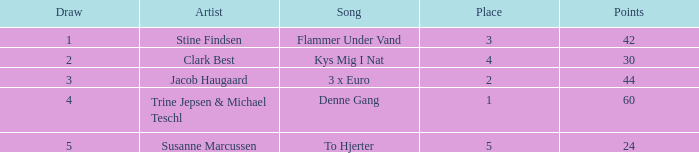What is the Draw that has Points larger than 44 and a Place larger than 1? None. 